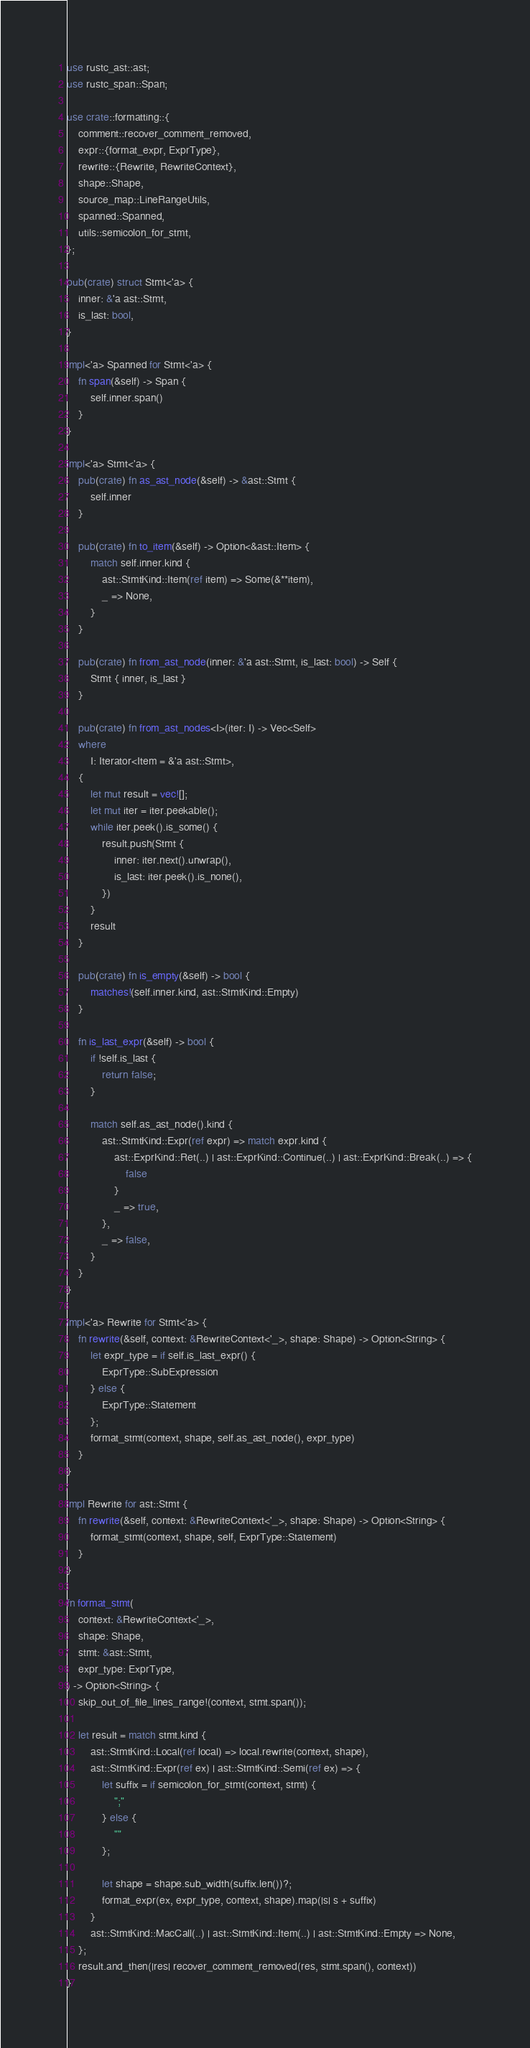Convert code to text. <code><loc_0><loc_0><loc_500><loc_500><_Rust_>use rustc_ast::ast;
use rustc_span::Span;

use crate::formatting::{
    comment::recover_comment_removed,
    expr::{format_expr, ExprType},
    rewrite::{Rewrite, RewriteContext},
    shape::Shape,
    source_map::LineRangeUtils,
    spanned::Spanned,
    utils::semicolon_for_stmt,
};

pub(crate) struct Stmt<'a> {
    inner: &'a ast::Stmt,
    is_last: bool,
}

impl<'a> Spanned for Stmt<'a> {
    fn span(&self) -> Span {
        self.inner.span()
    }
}

impl<'a> Stmt<'a> {
    pub(crate) fn as_ast_node(&self) -> &ast::Stmt {
        self.inner
    }

    pub(crate) fn to_item(&self) -> Option<&ast::Item> {
        match self.inner.kind {
            ast::StmtKind::Item(ref item) => Some(&**item),
            _ => None,
        }
    }

    pub(crate) fn from_ast_node(inner: &'a ast::Stmt, is_last: bool) -> Self {
        Stmt { inner, is_last }
    }

    pub(crate) fn from_ast_nodes<I>(iter: I) -> Vec<Self>
    where
        I: Iterator<Item = &'a ast::Stmt>,
    {
        let mut result = vec![];
        let mut iter = iter.peekable();
        while iter.peek().is_some() {
            result.push(Stmt {
                inner: iter.next().unwrap(),
                is_last: iter.peek().is_none(),
            })
        }
        result
    }

    pub(crate) fn is_empty(&self) -> bool {
        matches!(self.inner.kind, ast::StmtKind::Empty)
    }

    fn is_last_expr(&self) -> bool {
        if !self.is_last {
            return false;
        }

        match self.as_ast_node().kind {
            ast::StmtKind::Expr(ref expr) => match expr.kind {
                ast::ExprKind::Ret(..) | ast::ExprKind::Continue(..) | ast::ExprKind::Break(..) => {
                    false
                }
                _ => true,
            },
            _ => false,
        }
    }
}

impl<'a> Rewrite for Stmt<'a> {
    fn rewrite(&self, context: &RewriteContext<'_>, shape: Shape) -> Option<String> {
        let expr_type = if self.is_last_expr() {
            ExprType::SubExpression
        } else {
            ExprType::Statement
        };
        format_stmt(context, shape, self.as_ast_node(), expr_type)
    }
}

impl Rewrite for ast::Stmt {
    fn rewrite(&self, context: &RewriteContext<'_>, shape: Shape) -> Option<String> {
        format_stmt(context, shape, self, ExprType::Statement)
    }
}

fn format_stmt(
    context: &RewriteContext<'_>,
    shape: Shape,
    stmt: &ast::Stmt,
    expr_type: ExprType,
) -> Option<String> {
    skip_out_of_file_lines_range!(context, stmt.span());

    let result = match stmt.kind {
        ast::StmtKind::Local(ref local) => local.rewrite(context, shape),
        ast::StmtKind::Expr(ref ex) | ast::StmtKind::Semi(ref ex) => {
            let suffix = if semicolon_for_stmt(context, stmt) {
                ";"
            } else {
                ""
            };

            let shape = shape.sub_width(suffix.len())?;
            format_expr(ex, expr_type, context, shape).map(|s| s + suffix)
        }
        ast::StmtKind::MacCall(..) | ast::StmtKind::Item(..) | ast::StmtKind::Empty => None,
    };
    result.and_then(|res| recover_comment_removed(res, stmt.span(), context))
}
</code> 